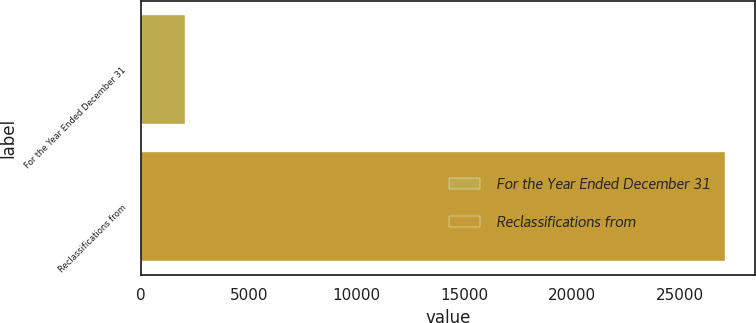Convert chart. <chart><loc_0><loc_0><loc_500><loc_500><bar_chart><fcel>For the Year Ended December 31<fcel>Reclassifications from<nl><fcel>2018<fcel>27111<nl></chart> 